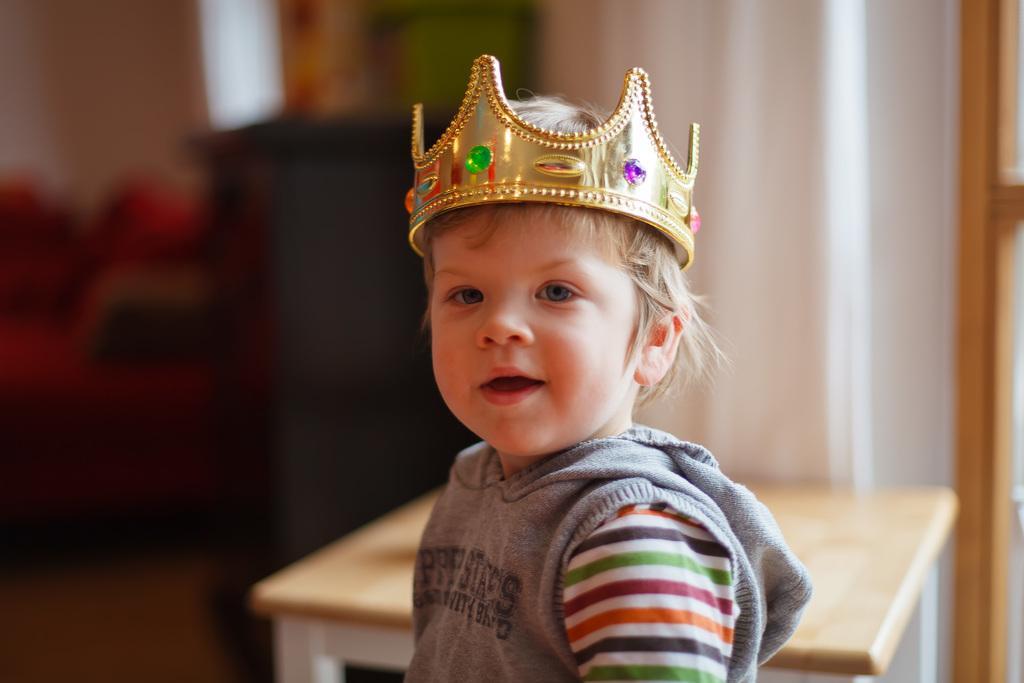Can you describe this image briefly? A boy wore a crown. Background it is blur. We can see table and wall. 